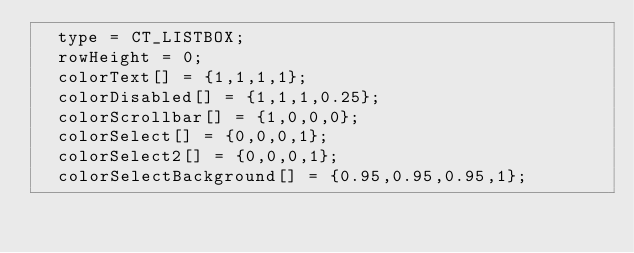Convert code to text. <code><loc_0><loc_0><loc_500><loc_500><_C++_>	type = CT_LISTBOX;
	rowHeight = 0;
	colorText[] = {1,1,1,1};
	colorDisabled[] = {1,1,1,0.25};
	colorScrollbar[] = {1,0,0,0};
	colorSelect[] = {0,0,0,1};
	colorSelect2[] = {0,0,0,1};
	colorSelectBackground[] = {0.95,0.95,0.95,1};</code> 